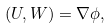<formula> <loc_0><loc_0><loc_500><loc_500>( U , W ) = \nabla \phi ,</formula> 